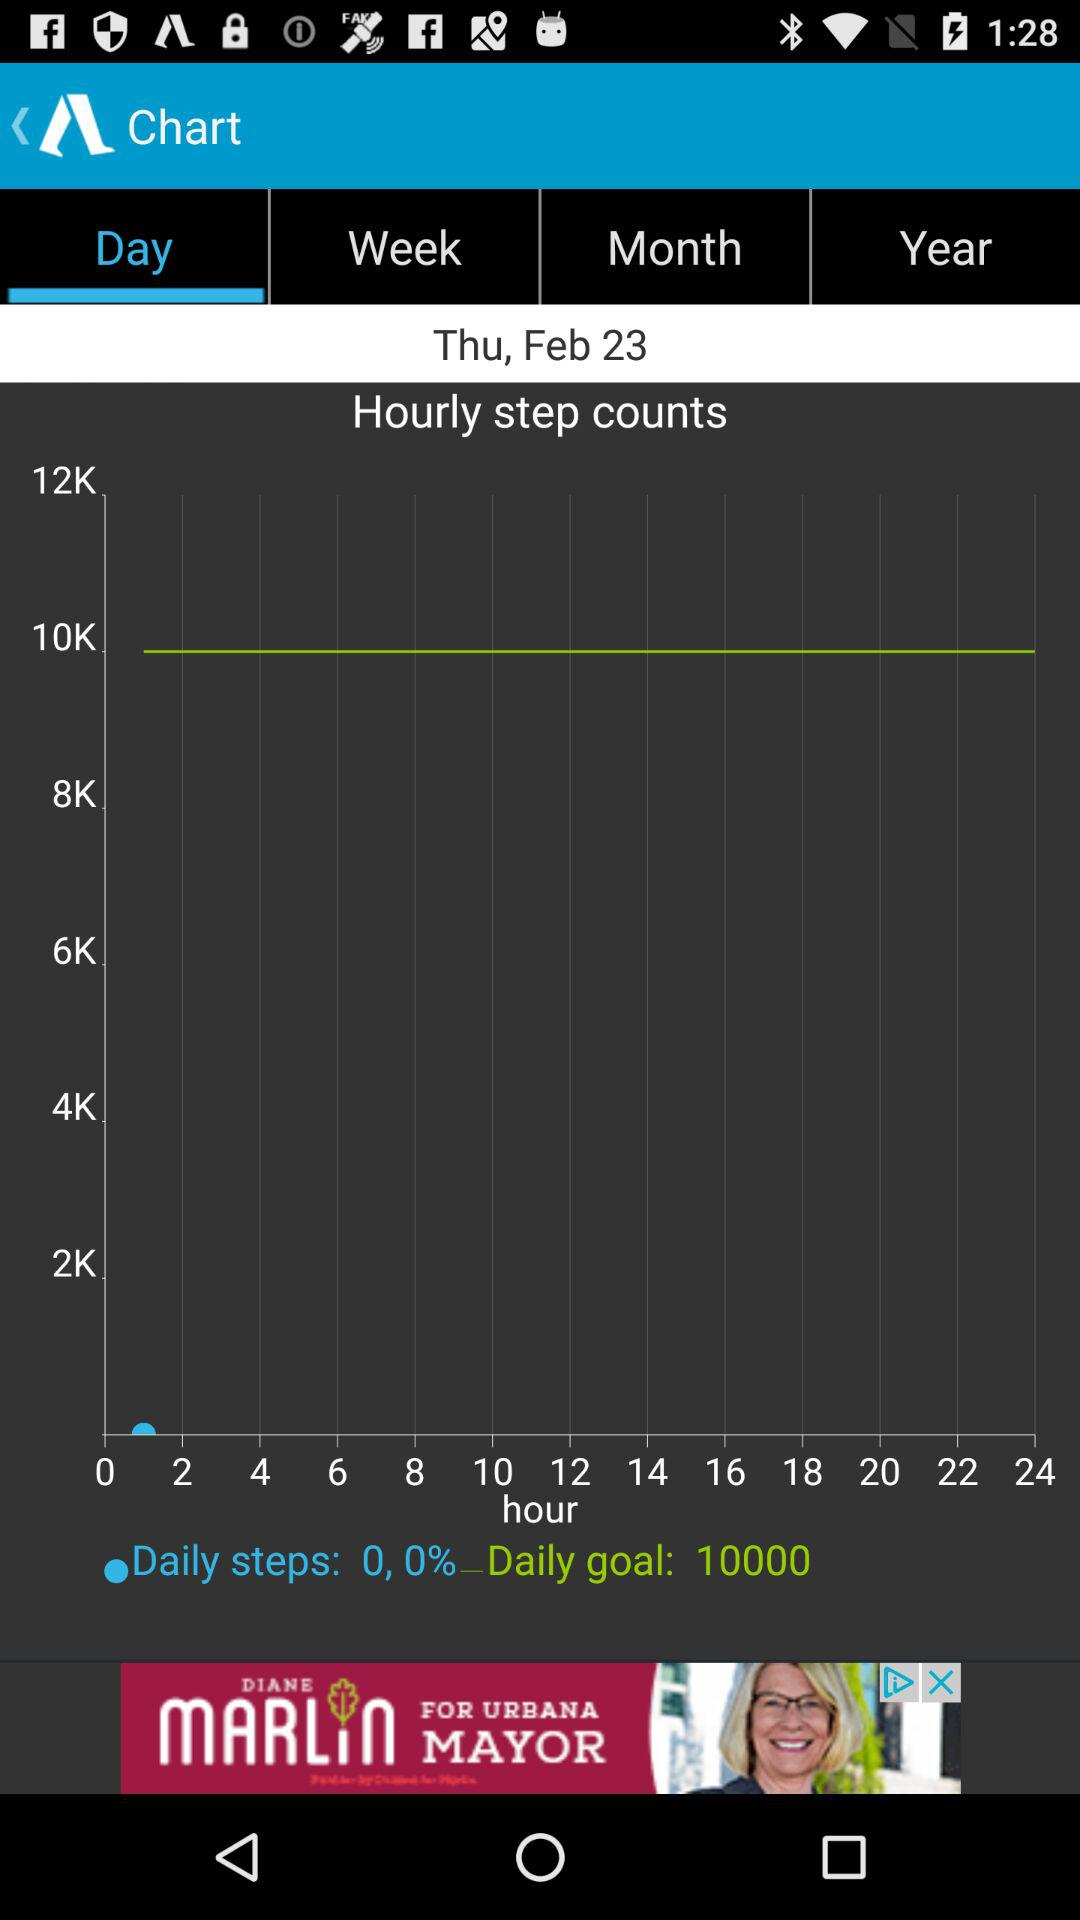What is the day on the given date? The day is Thursday. 